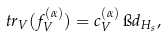Convert formula to latex. <formula><loc_0><loc_0><loc_500><loc_500>\ t r _ { V } ( f ^ { ( \alpha ) } _ { V } ) = c ^ { ( \alpha ) } _ { V } \, \i d _ { H _ { s } } ,</formula> 